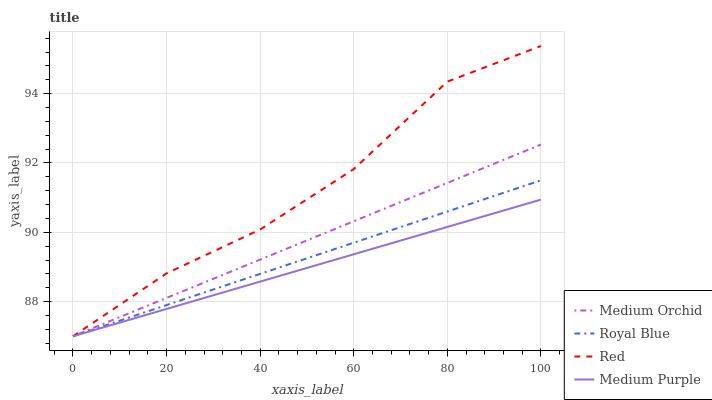Does Medium Purple have the minimum area under the curve?
Answer yes or no. Yes. Does Red have the maximum area under the curve?
Answer yes or no. Yes. Does Royal Blue have the minimum area under the curve?
Answer yes or no. No. Does Royal Blue have the maximum area under the curve?
Answer yes or no. No. Is Medium Purple the smoothest?
Answer yes or no. Yes. Is Red the roughest?
Answer yes or no. Yes. Is Royal Blue the smoothest?
Answer yes or no. No. Is Royal Blue the roughest?
Answer yes or no. No. Does Medium Purple have the lowest value?
Answer yes or no. Yes. Does Red have the highest value?
Answer yes or no. Yes. Does Royal Blue have the highest value?
Answer yes or no. No. Does Medium Orchid intersect Red?
Answer yes or no. Yes. Is Medium Orchid less than Red?
Answer yes or no. No. Is Medium Orchid greater than Red?
Answer yes or no. No. 